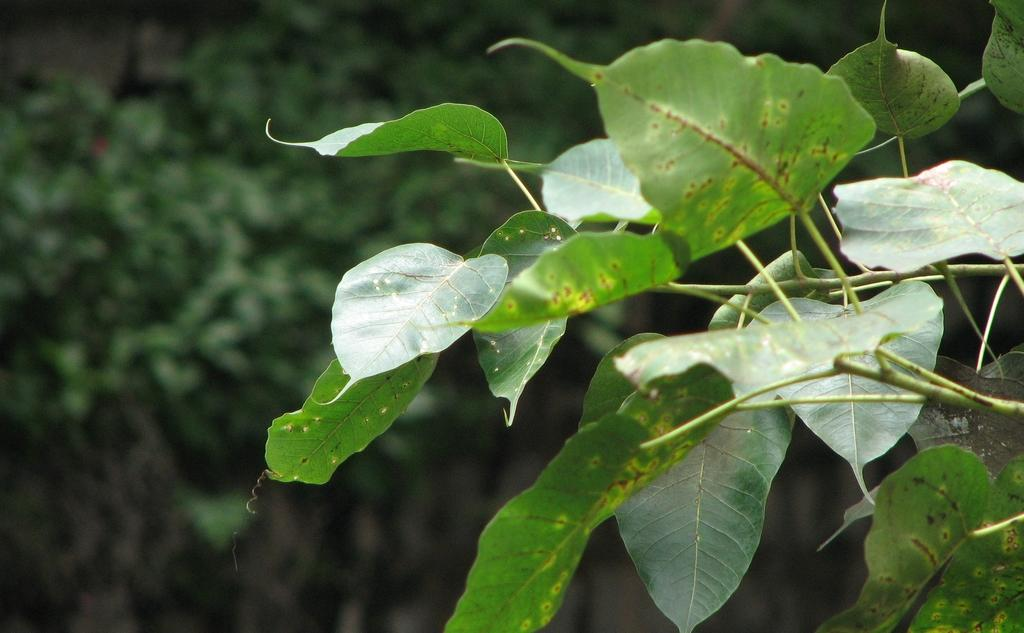What is the main subject of the image? The main subject of the image is a zoomed-in picture of leaves. Where are the leaves located in the image? The leaves are on the right side of the image. What type of hose can be seen connected to the lamp in the image? There is no hose or lamp present in the image; it only features a zoomed-in picture of leaves. 